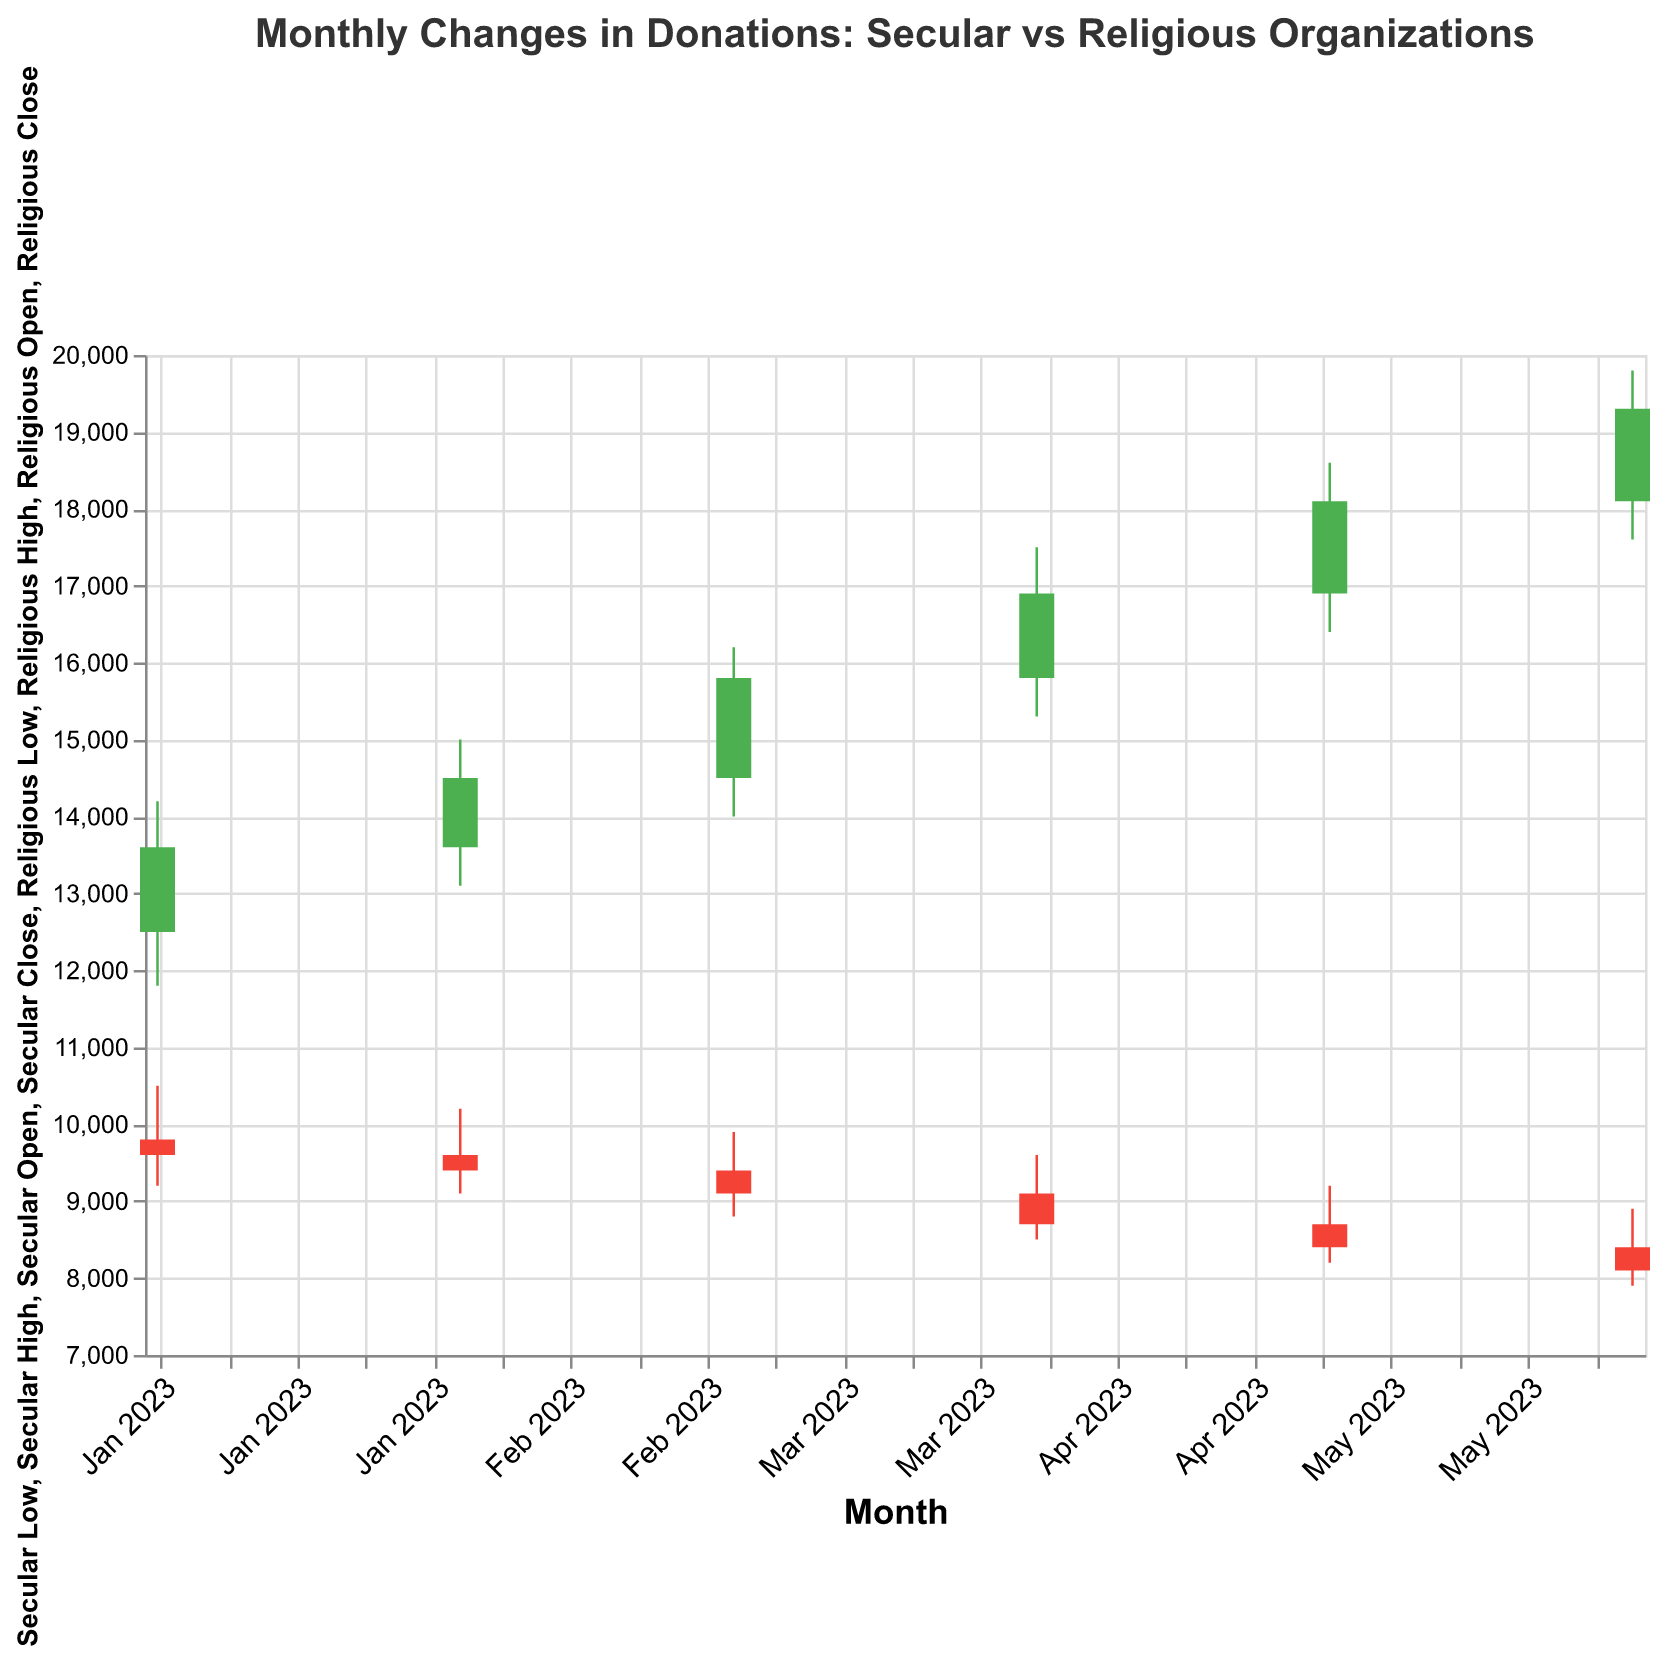What's the title of the figure? The title is usually displayed at the top of the chart. In this case, it would read "Monthly Changes in Donations: Secular vs Religious Organizations"
Answer: Monthly Changes in Donations: Secular vs Religious Organizations What are the represented date ranges on the X-axis? The X-axis shows dates in a monthly format. The data spans from January 2023 to June 2023, as evident from the values specified under the "Date" field in the data.
Answer: January 2023 to June 2023 Which organization had a higher closing value in January 2023? To find this, compare the "Secular Close" and "Religious Close" for January 2023. Secular Close is £13600 and Religious Close is £9600, hence the Secular organization had a higher closing value.
Answer: Secular organization By how much did the closing value for secular organizations increase from January to June 2023? The Secular Close in January is £13600 and in June is £19300. To find the increase, subtract the January value from the June value: £19300 - £13600 = £5700.
Answer: £5700 In which month did the religious organizations see their highest donation high value, and what was the value? Look at the "Religious High" values across all months. The highest value is £10500 in January 2023.
Answer: January 2023, £10500 Compare the opening value of secular organizations in January and June. Which month had a higher opening value? Compare the "Secular Open" values for January (£12500) and June (£18100). June has a higher opening value.
Answer: June What was the lowest donation value recorded for religious organizations over the 6 months? Identify the smallest "Religious Low" value in the dataset. The lowest is £7900 in June 2023.
Answer: £7900 How did the closing values from March to April change for both secular and religious organizations? For secular organizations: March (£15800) to April (£16900), there's an increase of £1100. For religious organizations: March (£9100) to April (£8700), there's a decrease of £400.
Answer: Secular increased by £1100, Religious decreased by £400 When did secular organizations have the smallest range between high and low values? Calculate the range (High - Low) for each month for secular organizations and find the smallest. In February, the range is £15000 - £13100 = £1900, which is the smallest.
Answer: February 